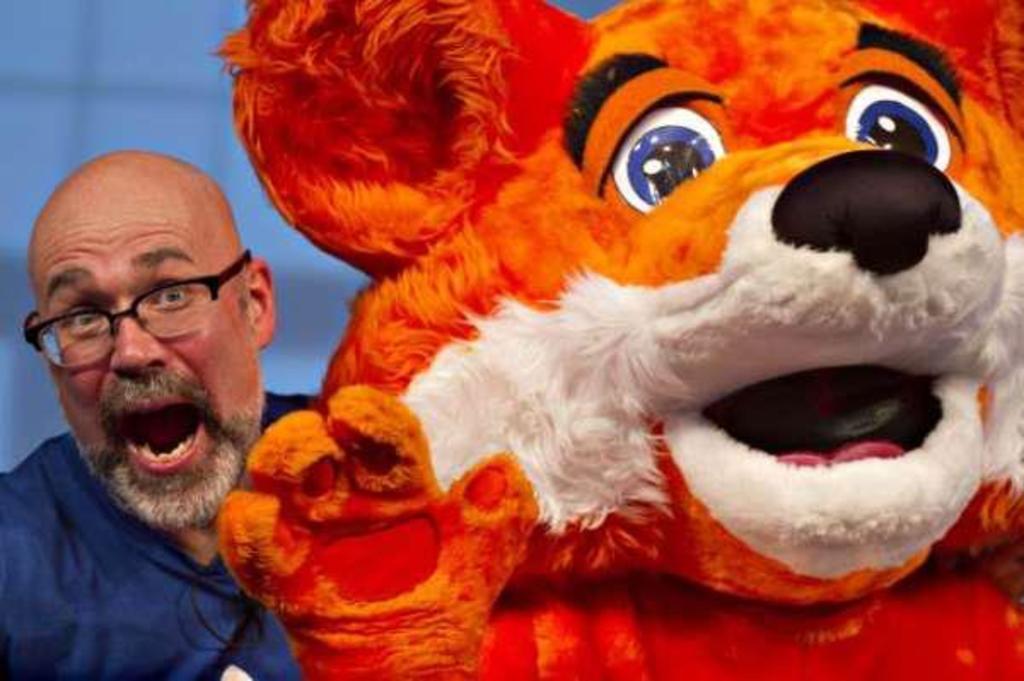In one or two sentences, can you explain what this image depicts? In this image I can see a person and another person in costume. In the background I can see blue color. This image is taken may be on the stage. 